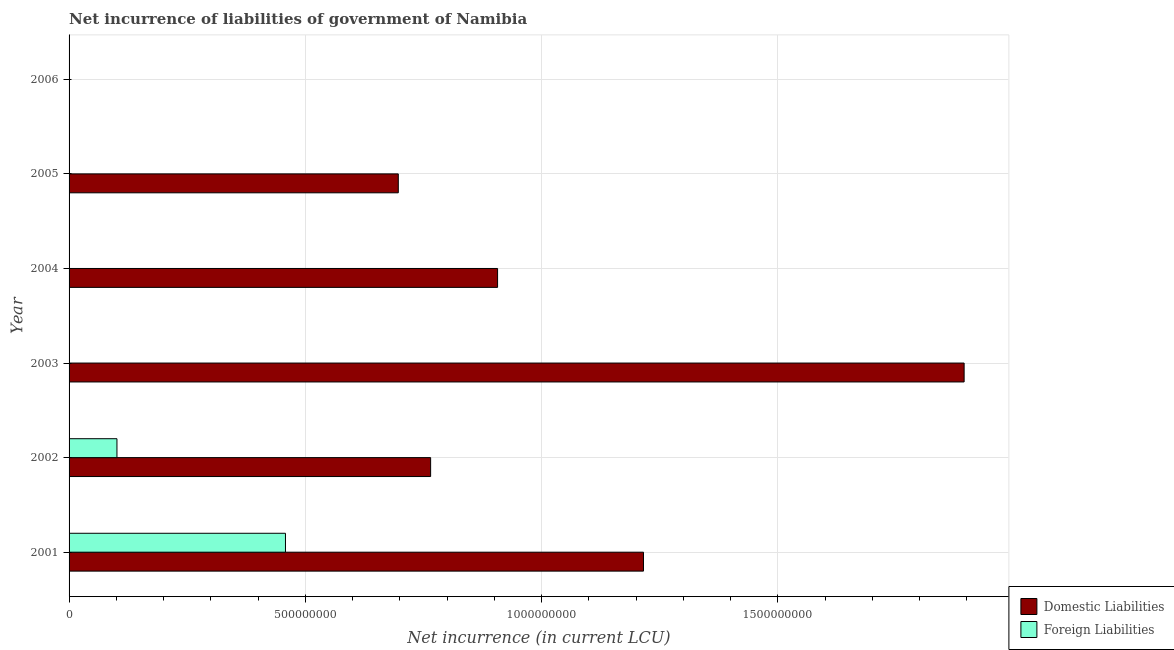How many different coloured bars are there?
Provide a succinct answer. 2. Are the number of bars on each tick of the Y-axis equal?
Ensure brevity in your answer.  No. How many bars are there on the 2nd tick from the bottom?
Your response must be concise. 2. What is the label of the 4th group of bars from the top?
Make the answer very short. 2003. Across all years, what is the maximum net incurrence of foreign liabilities?
Provide a short and direct response. 4.58e+08. Across all years, what is the minimum net incurrence of domestic liabilities?
Make the answer very short. 0. In which year was the net incurrence of domestic liabilities maximum?
Offer a terse response. 2003. What is the total net incurrence of domestic liabilities in the graph?
Make the answer very short. 5.48e+09. What is the difference between the net incurrence of domestic liabilities in 2001 and that in 2002?
Provide a short and direct response. 4.50e+08. What is the difference between the net incurrence of foreign liabilities in 2005 and the net incurrence of domestic liabilities in 2001?
Offer a terse response. -1.22e+09. What is the average net incurrence of foreign liabilities per year?
Your answer should be very brief. 9.32e+07. In the year 2002, what is the difference between the net incurrence of domestic liabilities and net incurrence of foreign liabilities?
Provide a short and direct response. 6.64e+08. Is the net incurrence of domestic liabilities in 2003 less than that in 2004?
Make the answer very short. No. Is the difference between the net incurrence of foreign liabilities in 2001 and 2002 greater than the difference between the net incurrence of domestic liabilities in 2001 and 2002?
Offer a terse response. No. What is the difference between the highest and the second highest net incurrence of domestic liabilities?
Offer a very short reply. 6.79e+08. What is the difference between the highest and the lowest net incurrence of foreign liabilities?
Provide a succinct answer. 4.58e+08. How many years are there in the graph?
Your answer should be very brief. 6. What is the difference between two consecutive major ticks on the X-axis?
Your answer should be very brief. 5.00e+08. Are the values on the major ticks of X-axis written in scientific E-notation?
Your answer should be very brief. No. Does the graph contain any zero values?
Ensure brevity in your answer.  Yes. Where does the legend appear in the graph?
Your response must be concise. Bottom right. How many legend labels are there?
Provide a short and direct response. 2. What is the title of the graph?
Your answer should be compact. Net incurrence of liabilities of government of Namibia. Does "GDP per capita" appear as one of the legend labels in the graph?
Offer a terse response. No. What is the label or title of the X-axis?
Offer a terse response. Net incurrence (in current LCU). What is the label or title of the Y-axis?
Give a very brief answer. Year. What is the Net incurrence (in current LCU) of Domestic Liabilities in 2001?
Ensure brevity in your answer.  1.22e+09. What is the Net incurrence (in current LCU) in Foreign Liabilities in 2001?
Give a very brief answer. 4.58e+08. What is the Net incurrence (in current LCU) of Domestic Liabilities in 2002?
Keep it short and to the point. 7.65e+08. What is the Net incurrence (in current LCU) of Foreign Liabilities in 2002?
Ensure brevity in your answer.  1.01e+08. What is the Net incurrence (in current LCU) in Domestic Liabilities in 2003?
Provide a short and direct response. 1.89e+09. What is the Net incurrence (in current LCU) of Domestic Liabilities in 2004?
Your answer should be very brief. 9.07e+08. What is the Net incurrence (in current LCU) of Foreign Liabilities in 2004?
Your response must be concise. 0. What is the Net incurrence (in current LCU) in Domestic Liabilities in 2005?
Offer a terse response. 6.97e+08. What is the Net incurrence (in current LCU) in Foreign Liabilities in 2005?
Ensure brevity in your answer.  0. What is the Net incurrence (in current LCU) in Foreign Liabilities in 2006?
Ensure brevity in your answer.  0. Across all years, what is the maximum Net incurrence (in current LCU) in Domestic Liabilities?
Your answer should be compact. 1.89e+09. Across all years, what is the maximum Net incurrence (in current LCU) of Foreign Liabilities?
Give a very brief answer. 4.58e+08. Across all years, what is the minimum Net incurrence (in current LCU) of Foreign Liabilities?
Offer a terse response. 0. What is the total Net incurrence (in current LCU) of Domestic Liabilities in the graph?
Ensure brevity in your answer.  5.48e+09. What is the total Net incurrence (in current LCU) in Foreign Liabilities in the graph?
Keep it short and to the point. 5.59e+08. What is the difference between the Net incurrence (in current LCU) of Domestic Liabilities in 2001 and that in 2002?
Offer a very short reply. 4.50e+08. What is the difference between the Net incurrence (in current LCU) in Foreign Liabilities in 2001 and that in 2002?
Offer a very short reply. 3.57e+08. What is the difference between the Net incurrence (in current LCU) of Domestic Liabilities in 2001 and that in 2003?
Your response must be concise. -6.79e+08. What is the difference between the Net incurrence (in current LCU) of Domestic Liabilities in 2001 and that in 2004?
Offer a very short reply. 3.09e+08. What is the difference between the Net incurrence (in current LCU) of Domestic Liabilities in 2001 and that in 2005?
Provide a succinct answer. 5.19e+08. What is the difference between the Net incurrence (in current LCU) of Domestic Liabilities in 2002 and that in 2003?
Your response must be concise. -1.13e+09. What is the difference between the Net incurrence (in current LCU) in Domestic Liabilities in 2002 and that in 2004?
Your answer should be very brief. -1.42e+08. What is the difference between the Net incurrence (in current LCU) of Domestic Liabilities in 2002 and that in 2005?
Keep it short and to the point. 6.84e+07. What is the difference between the Net incurrence (in current LCU) of Domestic Liabilities in 2003 and that in 2004?
Provide a short and direct response. 9.87e+08. What is the difference between the Net incurrence (in current LCU) in Domestic Liabilities in 2003 and that in 2005?
Offer a very short reply. 1.20e+09. What is the difference between the Net incurrence (in current LCU) of Domestic Liabilities in 2004 and that in 2005?
Your answer should be very brief. 2.10e+08. What is the difference between the Net incurrence (in current LCU) of Domestic Liabilities in 2001 and the Net incurrence (in current LCU) of Foreign Liabilities in 2002?
Provide a succinct answer. 1.11e+09. What is the average Net incurrence (in current LCU) of Domestic Liabilities per year?
Provide a succinct answer. 9.13e+08. What is the average Net incurrence (in current LCU) of Foreign Liabilities per year?
Make the answer very short. 9.32e+07. In the year 2001, what is the difference between the Net incurrence (in current LCU) of Domestic Liabilities and Net incurrence (in current LCU) of Foreign Liabilities?
Give a very brief answer. 7.58e+08. In the year 2002, what is the difference between the Net incurrence (in current LCU) in Domestic Liabilities and Net incurrence (in current LCU) in Foreign Liabilities?
Ensure brevity in your answer.  6.64e+08. What is the ratio of the Net incurrence (in current LCU) of Domestic Liabilities in 2001 to that in 2002?
Your answer should be compact. 1.59. What is the ratio of the Net incurrence (in current LCU) of Foreign Liabilities in 2001 to that in 2002?
Provide a short and direct response. 4.52. What is the ratio of the Net incurrence (in current LCU) of Domestic Liabilities in 2001 to that in 2003?
Ensure brevity in your answer.  0.64. What is the ratio of the Net incurrence (in current LCU) in Domestic Liabilities in 2001 to that in 2004?
Give a very brief answer. 1.34. What is the ratio of the Net incurrence (in current LCU) in Domestic Liabilities in 2001 to that in 2005?
Your response must be concise. 1.74. What is the ratio of the Net incurrence (in current LCU) in Domestic Liabilities in 2002 to that in 2003?
Provide a short and direct response. 0.4. What is the ratio of the Net incurrence (in current LCU) in Domestic Liabilities in 2002 to that in 2004?
Make the answer very short. 0.84. What is the ratio of the Net incurrence (in current LCU) of Domestic Liabilities in 2002 to that in 2005?
Offer a terse response. 1.1. What is the ratio of the Net incurrence (in current LCU) of Domestic Liabilities in 2003 to that in 2004?
Offer a very short reply. 2.09. What is the ratio of the Net incurrence (in current LCU) in Domestic Liabilities in 2003 to that in 2005?
Make the answer very short. 2.72. What is the ratio of the Net incurrence (in current LCU) in Domestic Liabilities in 2004 to that in 2005?
Offer a very short reply. 1.3. What is the difference between the highest and the second highest Net incurrence (in current LCU) in Domestic Liabilities?
Your response must be concise. 6.79e+08. What is the difference between the highest and the lowest Net incurrence (in current LCU) in Domestic Liabilities?
Your answer should be very brief. 1.89e+09. What is the difference between the highest and the lowest Net incurrence (in current LCU) in Foreign Liabilities?
Ensure brevity in your answer.  4.58e+08. 